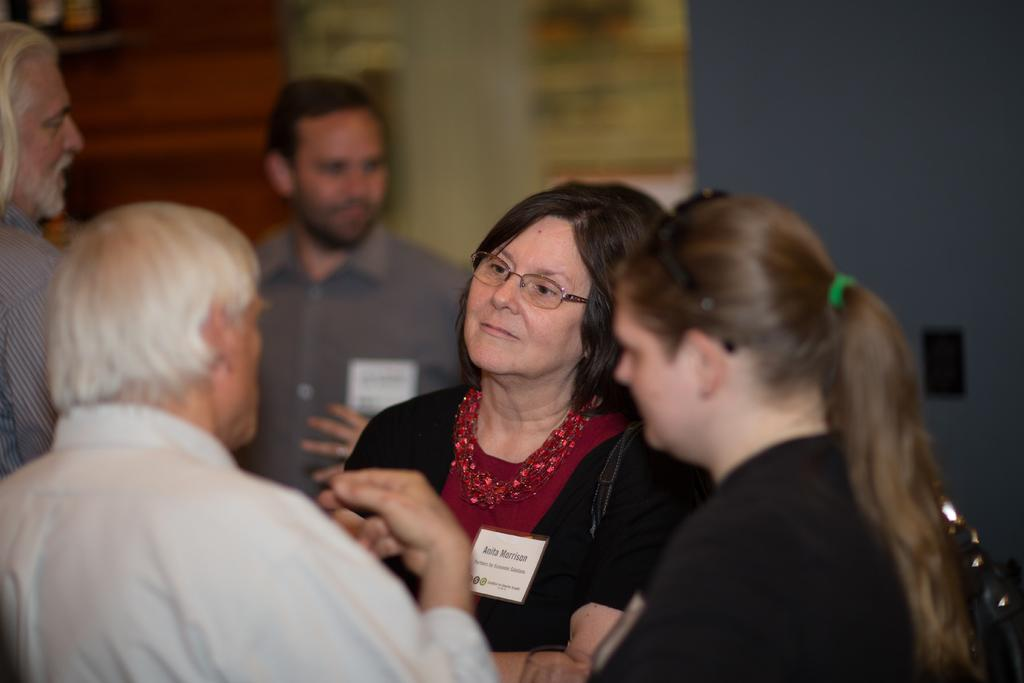What can be observed about the people in the image? There are people standing in the image. Can you describe the position of the woman in the group? A woman is in the middle of the group. What is the woman wearing that is noticeable? The woman is wearing spectacles. How would you describe the background of the image? The background of the image is blurry. What type of thread is the woman using to sew in the image? There is no thread or sewing activity present in the image. What do the people in the image believe about the bell? There is no bell or any indication of beliefs in the image. 